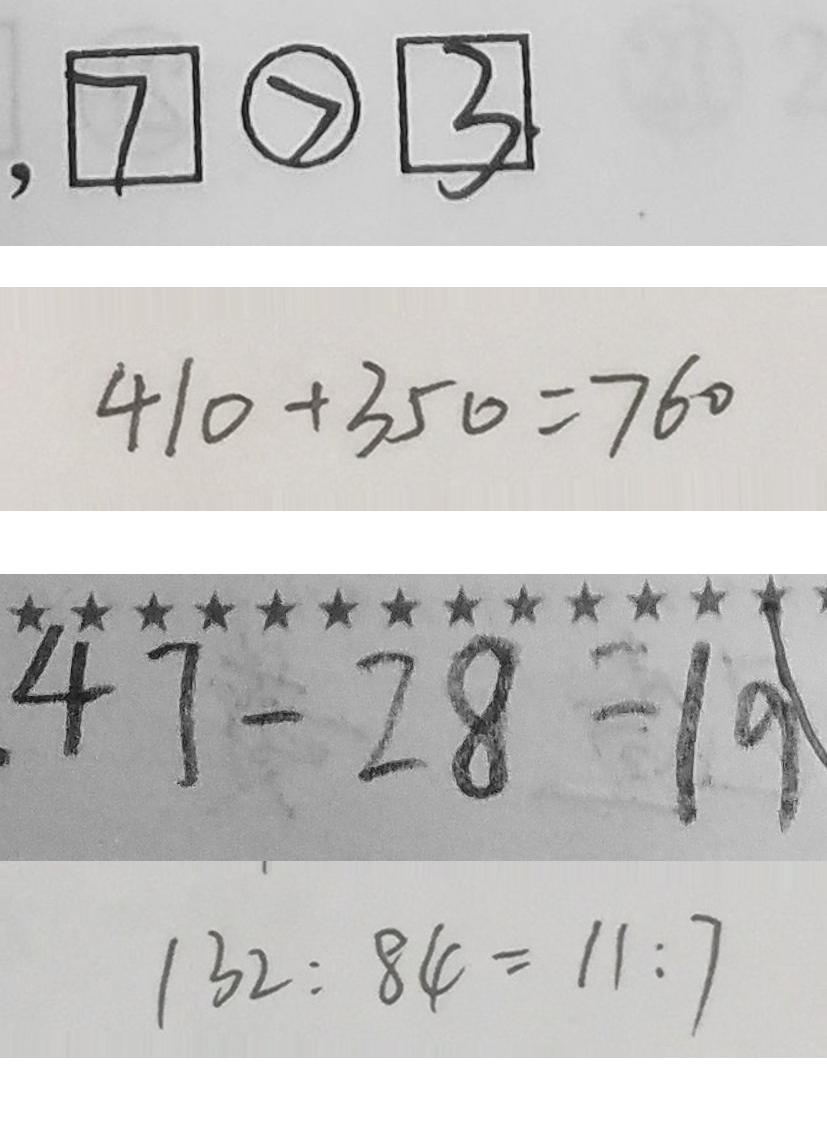<formula> <loc_0><loc_0><loc_500><loc_500>, \boxed { 7 } \textcircled { > } \boxed { 3 } 
 4 1 0 + 3 5 0 = 7 6 0 
 4 7 - 2 8 = 1 9 
 1 3 2 : 8 4 = 1 1 : 7</formula> 